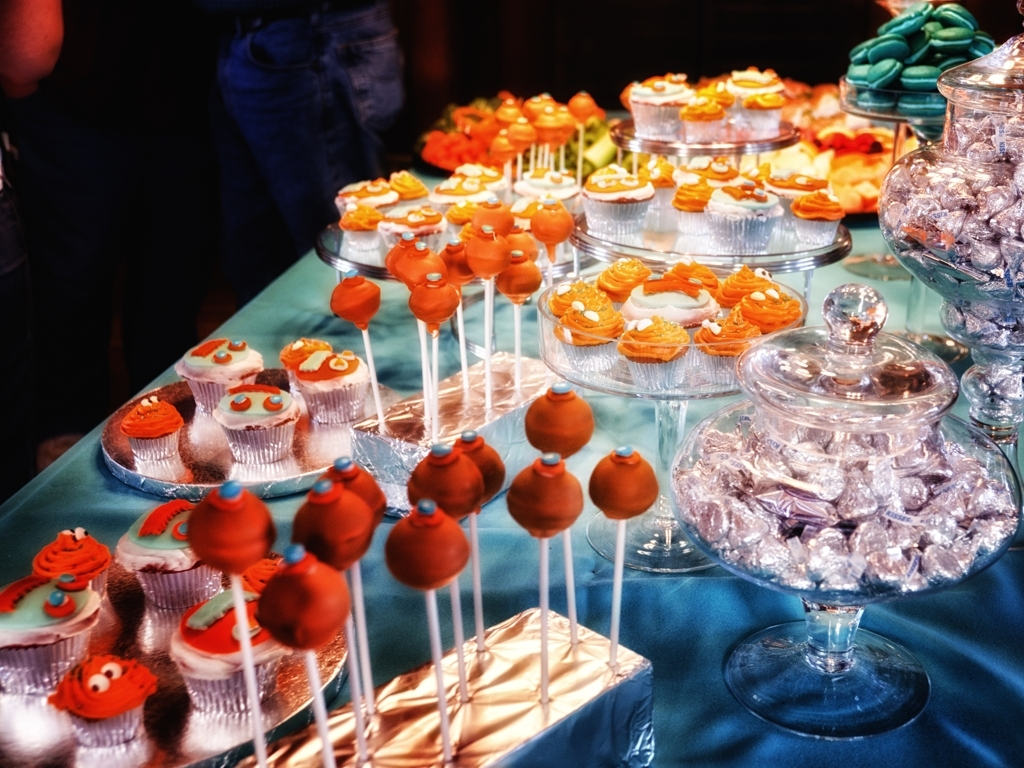Does the image look like a generated image? Based on the intricate details and the natural-looking color variations seen on the treats, as well as the soft shadows and ambient light, the image appears to be an authentic photograph rather than a computer-generated one. 